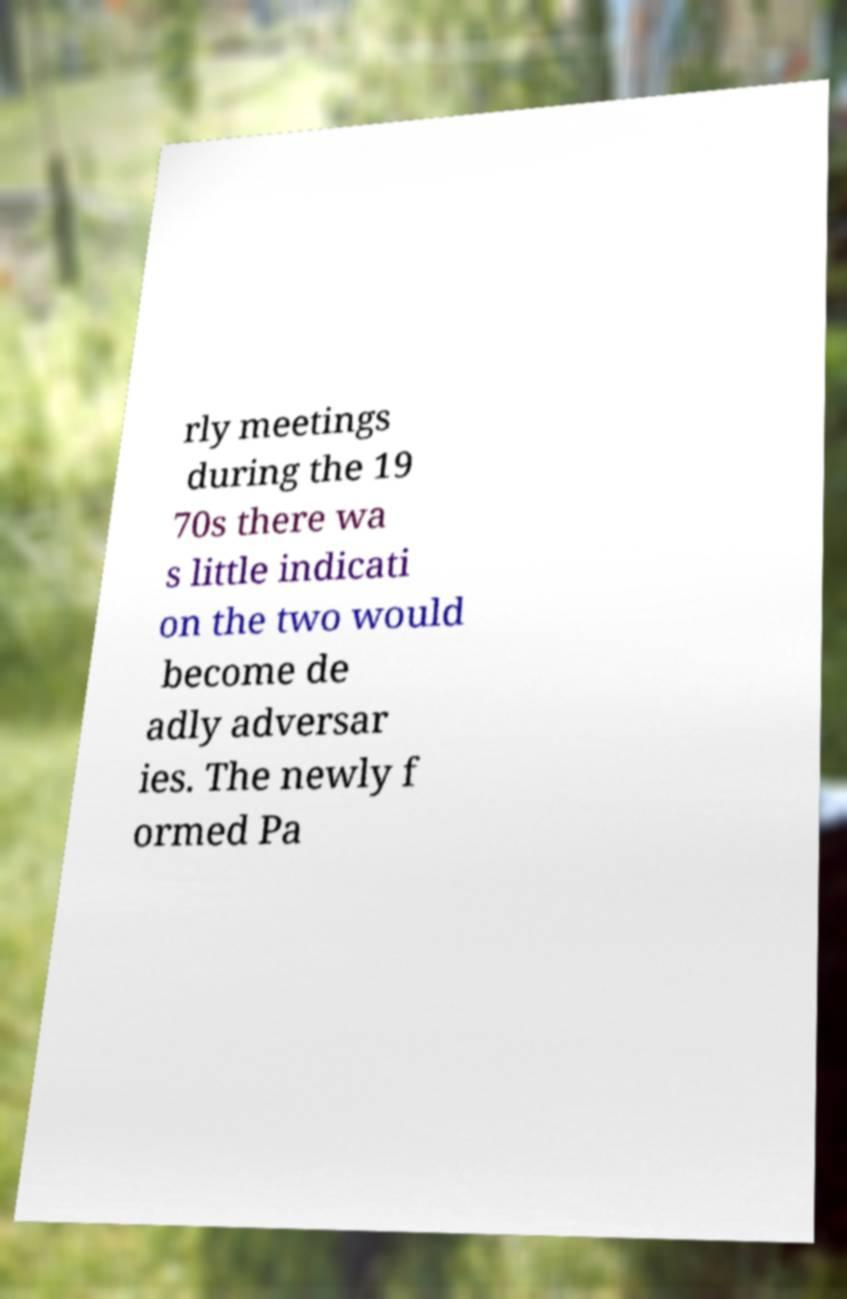What messages or text are displayed in this image? I need them in a readable, typed format. rly meetings during the 19 70s there wa s little indicati on the two would become de adly adversar ies. The newly f ormed Pa 